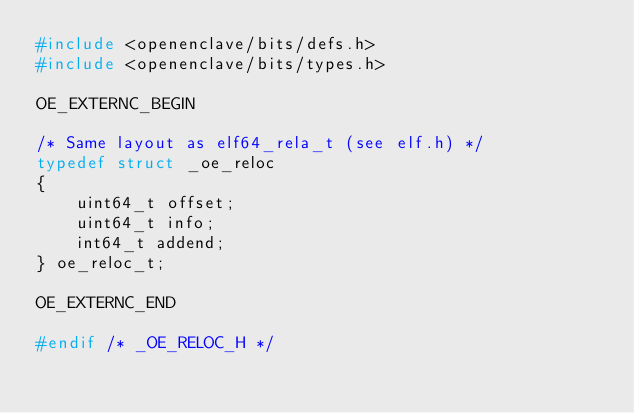Convert code to text. <code><loc_0><loc_0><loc_500><loc_500><_C_>#include <openenclave/bits/defs.h>
#include <openenclave/bits/types.h>

OE_EXTERNC_BEGIN

/* Same layout as elf64_rela_t (see elf.h) */
typedef struct _oe_reloc
{
    uint64_t offset;
    uint64_t info;
    int64_t addend;
} oe_reloc_t;

OE_EXTERNC_END

#endif /* _OE_RELOC_H */
</code> 